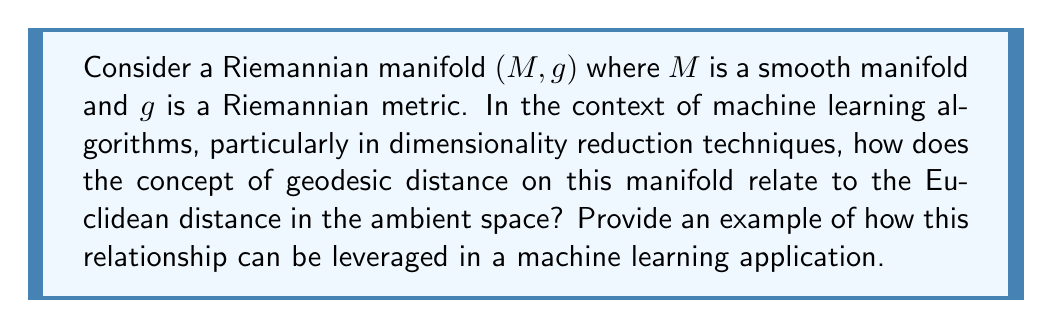Give your solution to this math problem. To understand this relationship, let's break down the concepts and their applications:

1. Riemannian Manifold:
   A Riemannian manifold $(M,g)$ is a smooth manifold $M$ equipped with a Riemannian metric $g$. The metric $g$ defines an inner product on each tangent space $T_pM$ at each point $p \in M$.

2. Geodesic Distance:
   The geodesic distance $d_g(p,q)$ between two points $p,q \in M$ is defined as the length of the shortest path (geodesic) connecting $p$ and $q$ on the manifold. It can be expressed as:

   $$d_g(p,q) = \inf_{\gamma} \int_0^1 \sqrt{g_{\gamma(t)}(\gamma'(t), \gamma'(t))} dt$$

   where $\gamma : [0,1] \rightarrow M$ is a smooth curve with $\gamma(0) = p$ and $\gamma(1) = q$.

3. Euclidean Distance:
   If $M$ is embedded in a Euclidean space $\mathbb{R}^n$, the Euclidean distance $d_E(p,q)$ between two points $p,q \in M$ is simply:

   $$d_E(p,q) = \sqrt{\sum_{i=1}^n (p_i - q_i)^2}$$

4. Relationship:
   The geodesic distance is always greater than or equal to the Euclidean distance:

   $$d_g(p,q) \geq d_E(p,q)$$

   This is because the geodesic follows the curvature of the manifold, while the Euclidean distance is a straight line in the ambient space.

5. Application in Machine Learning:
   In dimensionality reduction techniques like ISOMAP (Isometric Mapping), this relationship is leveraged to better preserve the intrinsic geometry of high-dimensional data.

   ISOMAP algorithm steps:
   a) Construct a neighborhood graph
   b) Compute geodesic distances using shortest path algorithms
   c) Apply Multidimensional Scaling (MDS) to the geodesic distance matrix

   By using geodesic distances instead of Euclidean distances, ISOMAP can capture the underlying manifold structure of the data, leading to more meaningful low-dimensional representations.

Example:
Consider a dataset of images of a rotating object. In the high-dimensional pixel space, images of slightly different rotations might be far apart in Euclidean distance. However, on the manifold of all possible rotations, these images are close in terms of geodesic distance. ISOMAP can recover this underlying circular structure by using geodesic distances, while linear methods like PCA using Euclidean distances might fail to do so.
Answer: The geodesic distance on a Riemannian manifold is always greater than or equal to the Euclidean distance in the ambient space. This relationship is leveraged in machine learning algorithms like ISOMAP for dimensionality reduction, where using geodesic distances helps preserve the intrinsic geometry of high-dimensional data, leading to more meaningful low-dimensional representations that capture the underlying manifold structure. 